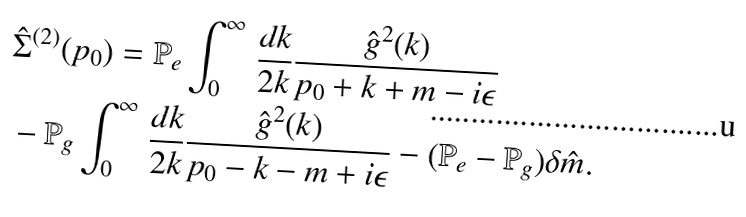<formula> <loc_0><loc_0><loc_500><loc_500>& { \hat { \Sigma } } ^ { ( 2 ) } ( p _ { 0 } ) = { \mathbb { P } } _ { e } \int _ { 0 } ^ { \infty } \, \frac { d k } { 2 k } \frac { \hat { g } ^ { 2 } ( k ) } { p _ { 0 } + k + m - i \epsilon } \\ & - { \mathbb { P } } _ { g } \int _ { 0 } ^ { \infty } \, \frac { d k } { 2 k } \frac { \hat { g } ^ { 2 } ( k ) } { p _ { 0 } - k - m + i \epsilon } - ( { \mathbb { P } } _ { e } - { \mathbb { P } } _ { g } ) \delta \hat { m } .</formula> 